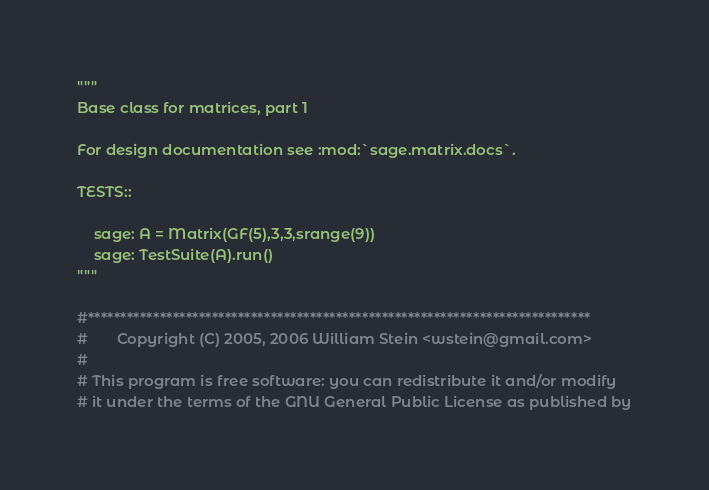Convert code to text. <code><loc_0><loc_0><loc_500><loc_500><_Cython_>"""
Base class for matrices, part 1

For design documentation see :mod:`sage.matrix.docs`.

TESTS::

    sage: A = Matrix(GF(5),3,3,srange(9))
    sage: TestSuite(A).run()
"""

#*****************************************************************************
#       Copyright (C) 2005, 2006 William Stein <wstein@gmail.com>
#
# This program is free software: you can redistribute it and/or modify
# it under the terms of the GNU General Public License as published by</code> 